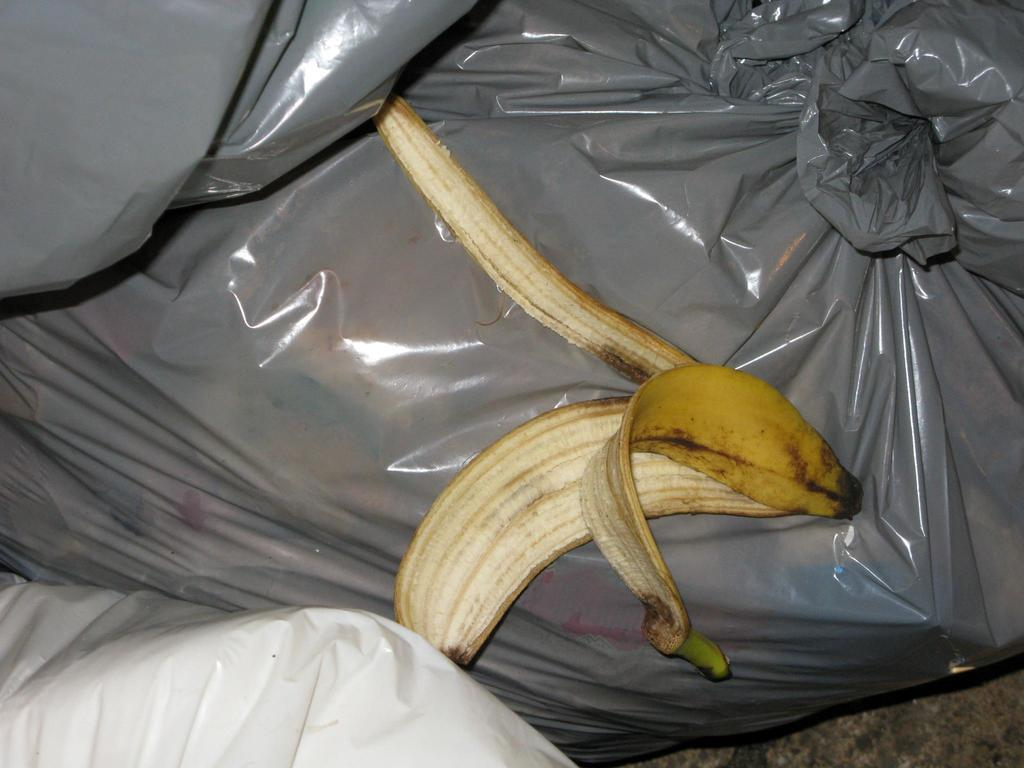What type of object can be seen in the image? There are plastic bags in the image. What colors are the plastic bags? The plastic bags are in ash and white color. What is present on one of the plastic bags? There is a banana peel on one of the plastic bags. What is the name of the chicken that is sitting on the office desk in the image? There is no chicken or office desk present in the image; it only features plastic bags and a banana peel. 